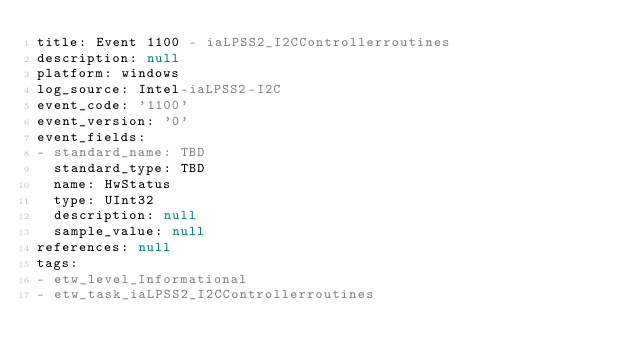<code> <loc_0><loc_0><loc_500><loc_500><_YAML_>title: Event 1100 - iaLPSS2_I2CControllerroutines
description: null
platform: windows
log_source: Intel-iaLPSS2-I2C
event_code: '1100'
event_version: '0'
event_fields:
- standard_name: TBD
  standard_type: TBD
  name: HwStatus
  type: UInt32
  description: null
  sample_value: null
references: null
tags:
- etw_level_Informational
- etw_task_iaLPSS2_I2CControllerroutines
</code> 